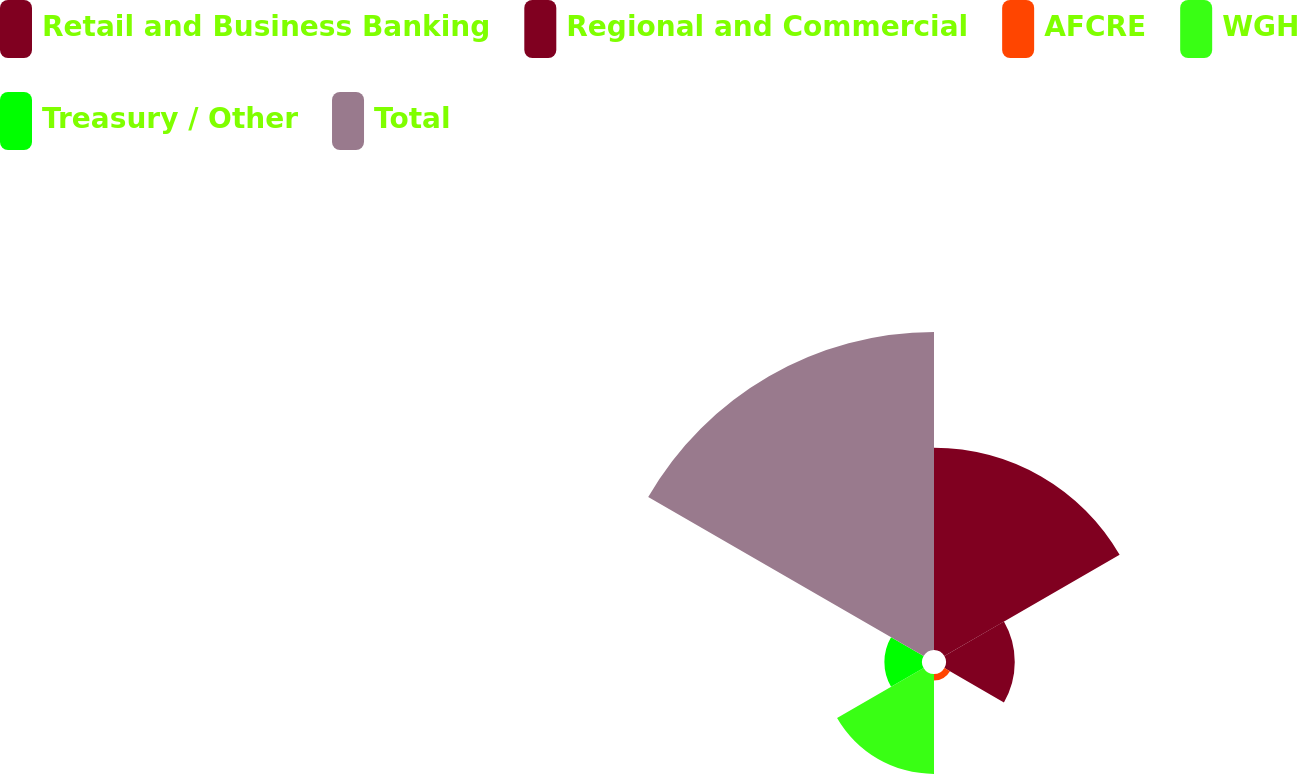Convert chart to OTSL. <chart><loc_0><loc_0><loc_500><loc_500><pie_chart><fcel>Retail and Business Banking<fcel>Regional and Commercial<fcel>AFCRE<fcel>WGH<fcel>Treasury / Other<fcel>Total<nl><fcel>27.6%<fcel>9.38%<fcel>0.88%<fcel>13.63%<fcel>5.13%<fcel>43.38%<nl></chart> 